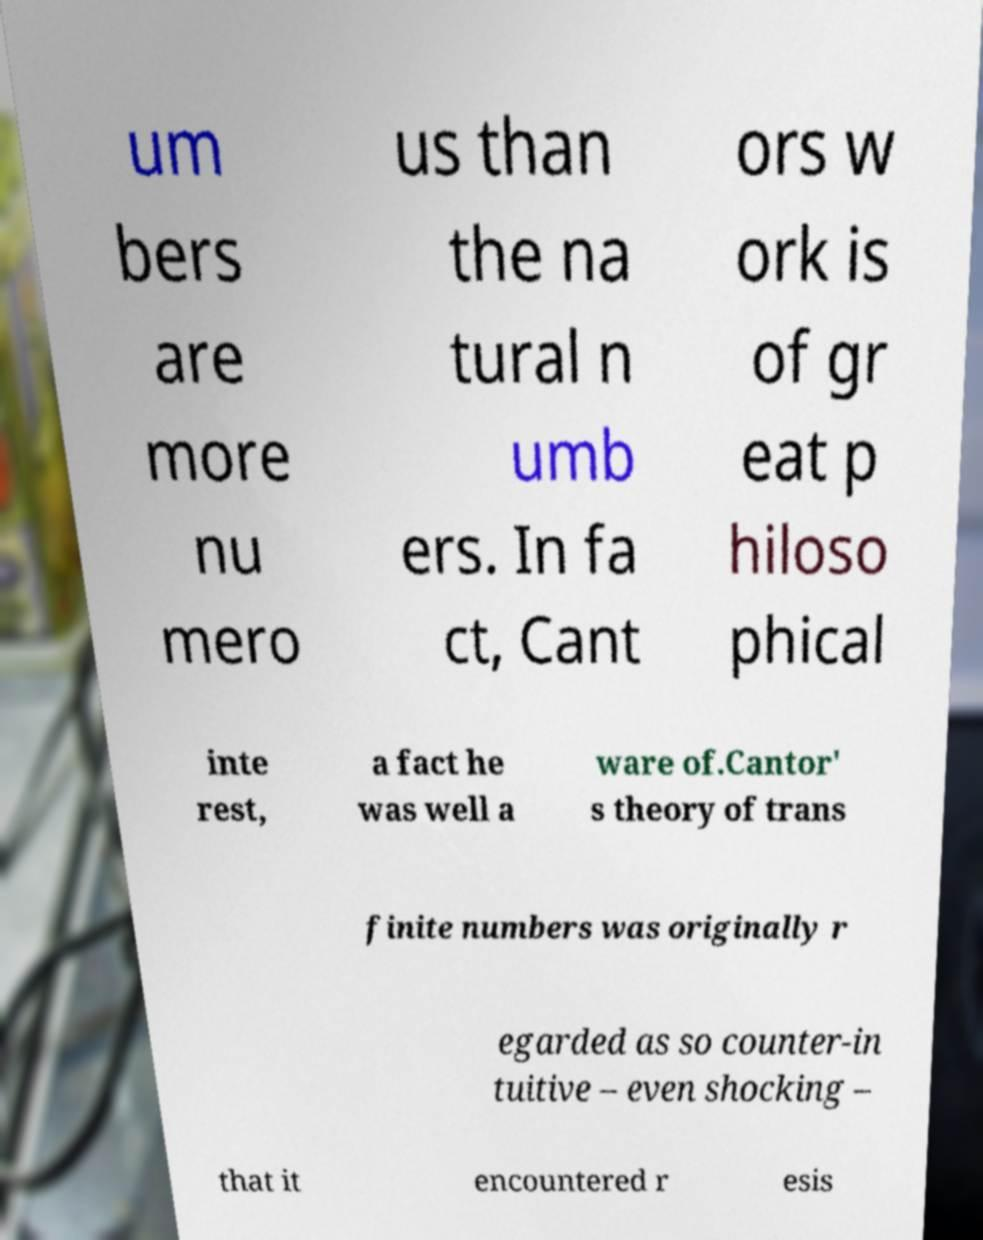Could you assist in decoding the text presented in this image and type it out clearly? um bers are more nu mero us than the na tural n umb ers. In fa ct, Cant ors w ork is of gr eat p hiloso phical inte rest, a fact he was well a ware of.Cantor' s theory of trans finite numbers was originally r egarded as so counter-in tuitive – even shocking – that it encountered r esis 